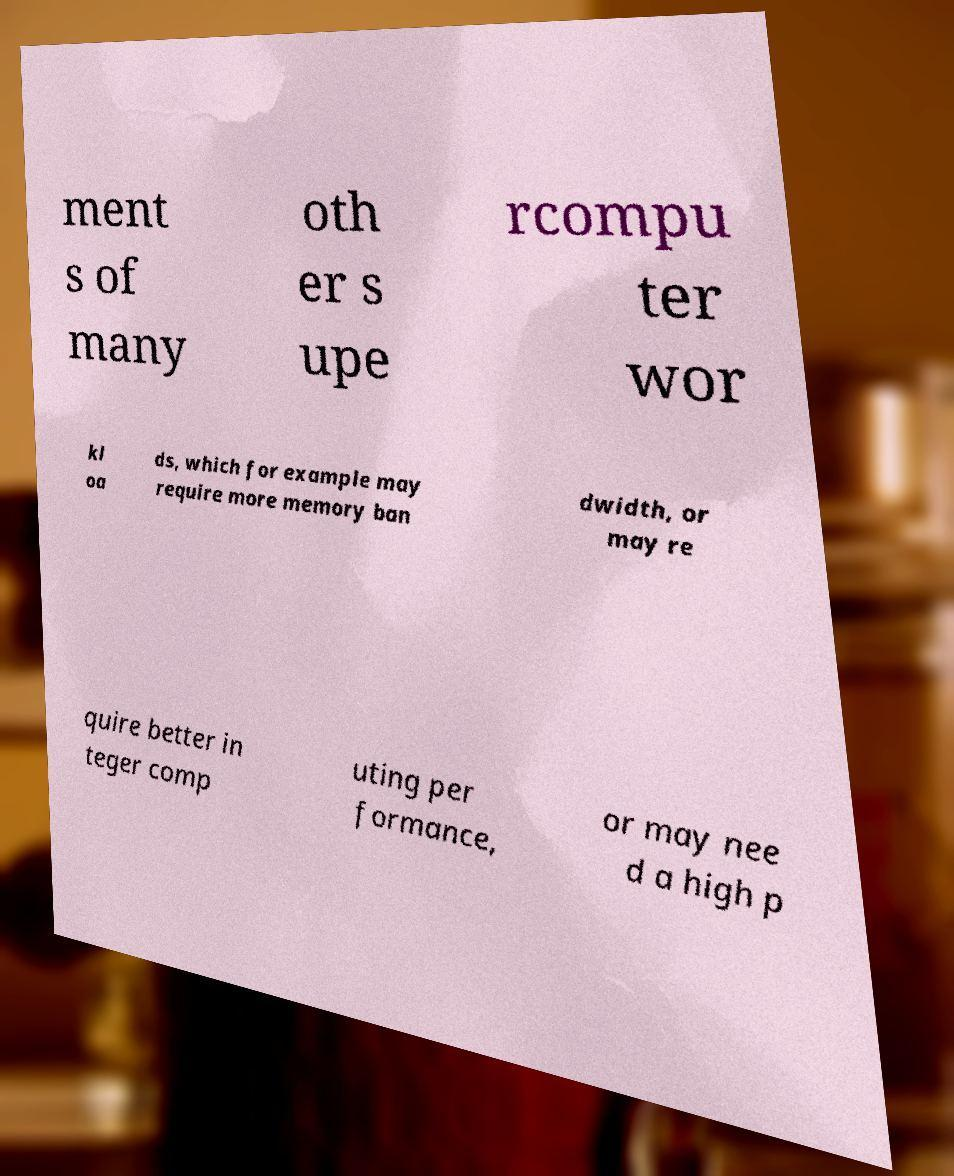Could you extract and type out the text from this image? ment s of many oth er s upe rcompu ter wor kl oa ds, which for example may require more memory ban dwidth, or may re quire better in teger comp uting per formance, or may nee d a high p 